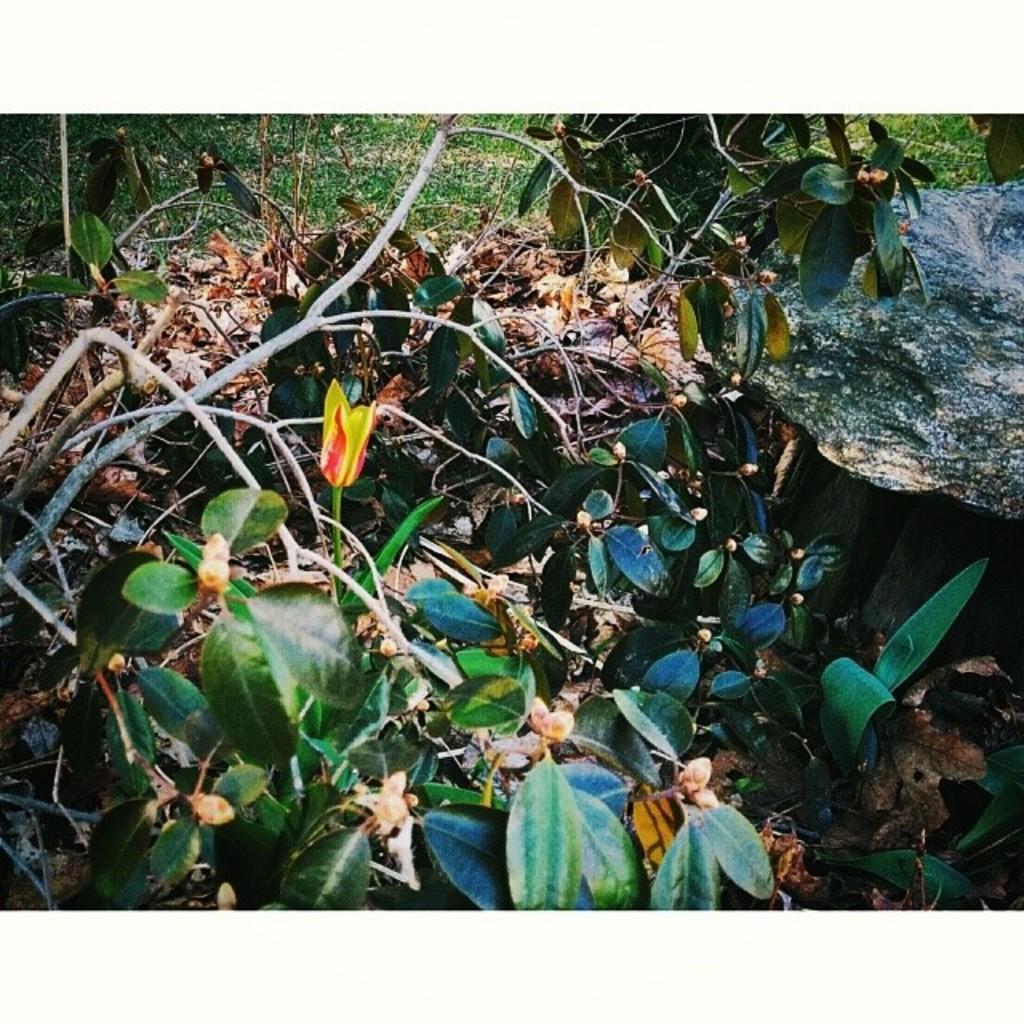Could you give a brief overview of what you see in this image? In this picture we can see plants, leaves and dry leaves and branches. 